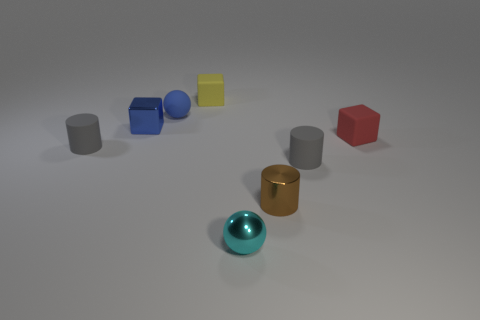Do the tiny cyan thing and the gray cylinder left of the tiny shiny cylinder have the same material?
Your answer should be compact. No. What is the material of the blue block that is the same size as the metallic cylinder?
Give a very brief answer. Metal. Is there a cyan matte cylinder of the same size as the blue matte thing?
Offer a very short reply. No. What is the shape of the blue matte object that is the same size as the yellow thing?
Your response must be concise. Sphere. What number of other things are the same color as the tiny metal sphere?
Offer a terse response. 0. There is a tiny shiny thing that is both left of the metal cylinder and behind the tiny cyan shiny sphere; what is its shape?
Keep it short and to the point. Cube. There is a gray thing on the right side of the matte block that is on the left side of the tiny red matte block; are there any tiny gray cylinders in front of it?
Provide a short and direct response. No. What number of other things are made of the same material as the yellow thing?
Your answer should be compact. 4. How many small cyan balls are there?
Your answer should be compact. 1. How many objects are brown rubber balls or small metal things behind the small brown cylinder?
Give a very brief answer. 1. 